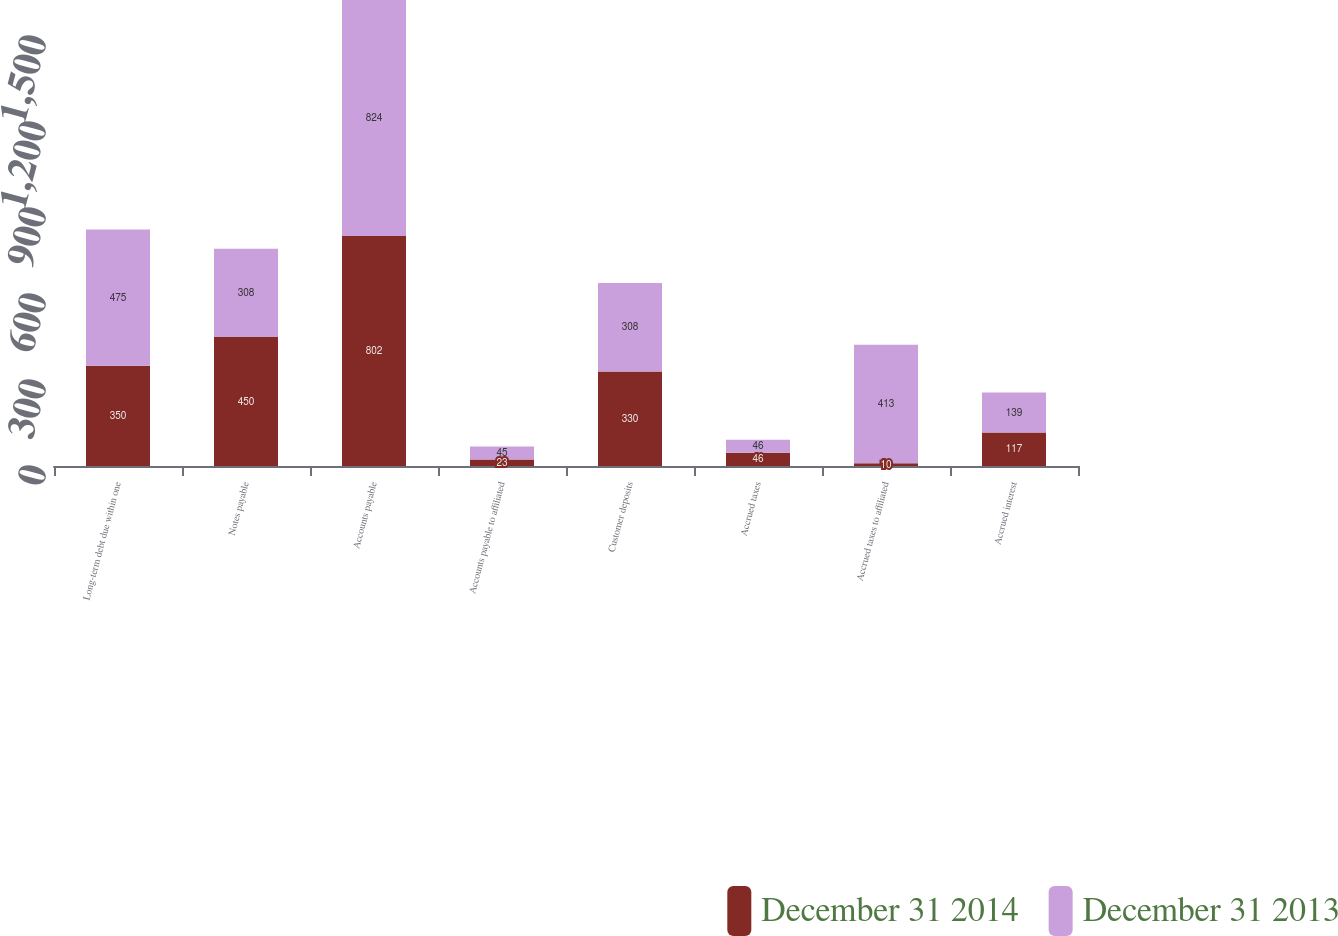Convert chart to OTSL. <chart><loc_0><loc_0><loc_500><loc_500><stacked_bar_chart><ecel><fcel>Long-term debt due within one<fcel>Notes payable<fcel>Accounts payable<fcel>Accounts payable to affiliated<fcel>Customer deposits<fcel>Accrued taxes<fcel>Accrued taxes to affiliated<fcel>Accrued interest<nl><fcel>December 31 2014<fcel>350<fcel>450<fcel>802<fcel>23<fcel>330<fcel>46<fcel>10<fcel>117<nl><fcel>December 31 2013<fcel>475<fcel>308<fcel>824<fcel>45<fcel>308<fcel>46<fcel>413<fcel>139<nl></chart> 